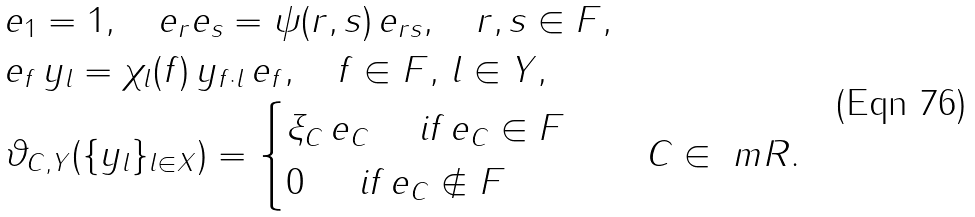Convert formula to latex. <formula><loc_0><loc_0><loc_500><loc_500>& e _ { 1 } = 1 , \quad e _ { r } e _ { s } = \psi ( r , s ) \, e _ { r s } , \quad r , s \in F , \\ & e _ { f } \, y _ { l } = \chi _ { l } ( f ) \, y _ { f \cdot l } \, e _ { f } , \quad f \in F , \, l \in Y , \\ & \vartheta _ { C , Y } ( \{ y _ { l } \} _ { l \in X } ) = \begin{cases} \xi _ { C } \, e _ { C } \quad \text { if } e _ { C } \in F \\ 0 \quad \, \text { if } e _ { C } \notin F \end{cases} \quad C \in \ m R .</formula> 